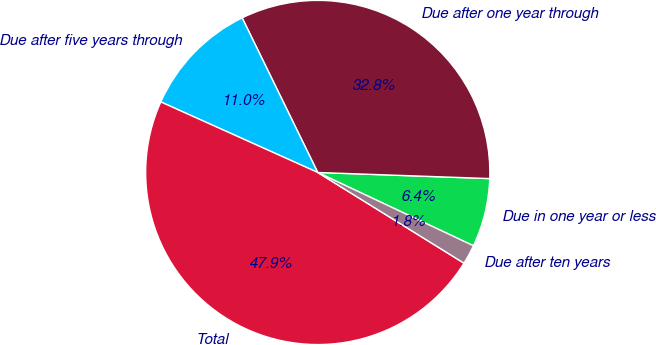Convert chart to OTSL. <chart><loc_0><loc_0><loc_500><loc_500><pie_chart><fcel>Due in one year or less<fcel>Due after one year through<fcel>Due after five years through<fcel>Total<fcel>Due after ten years<nl><fcel>6.44%<fcel>32.8%<fcel>11.04%<fcel>47.89%<fcel>1.83%<nl></chart> 